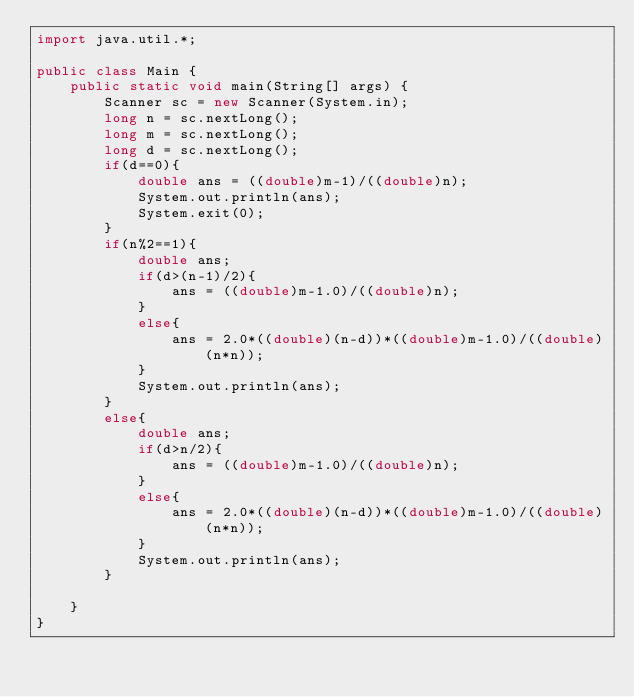Convert code to text. <code><loc_0><loc_0><loc_500><loc_500><_Java_>import java.util.*;

public class Main {
    public static void main(String[] args) {
        Scanner sc = new Scanner(System.in);
        long n = sc.nextLong();
        long m = sc.nextLong();
        long d = sc.nextLong();
        if(d==0){
            double ans = ((double)m-1)/((double)n);
            System.out.println(ans);
            System.exit(0);
        }
        if(n%2==1){
            double ans;
            if(d>(n-1)/2){
                ans = ((double)m-1.0)/((double)n);
            }
            else{
                ans = 2.0*((double)(n-d))*((double)m-1.0)/((double)(n*n));
            }
            System.out.println(ans);
        }
        else{
            double ans;
            if(d>n/2){
                ans = ((double)m-1.0)/((double)n);
            }
            else{
                ans = 2.0*((double)(n-d))*((double)m-1.0)/((double)(n*n));
            }
            System.out.println(ans);
        }

    }
}</code> 